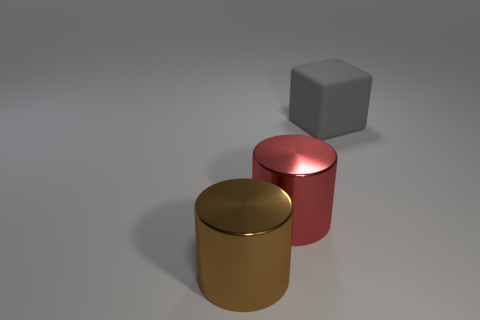Add 3 big shiny cylinders. How many objects exist? 6 Subtract all cubes. How many objects are left? 2 Add 2 red cylinders. How many red cylinders are left? 3 Add 2 tiny blue metal objects. How many tiny blue metal objects exist? 2 Subtract 0 blue cylinders. How many objects are left? 3 Subtract all big purple things. Subtract all gray cubes. How many objects are left? 2 